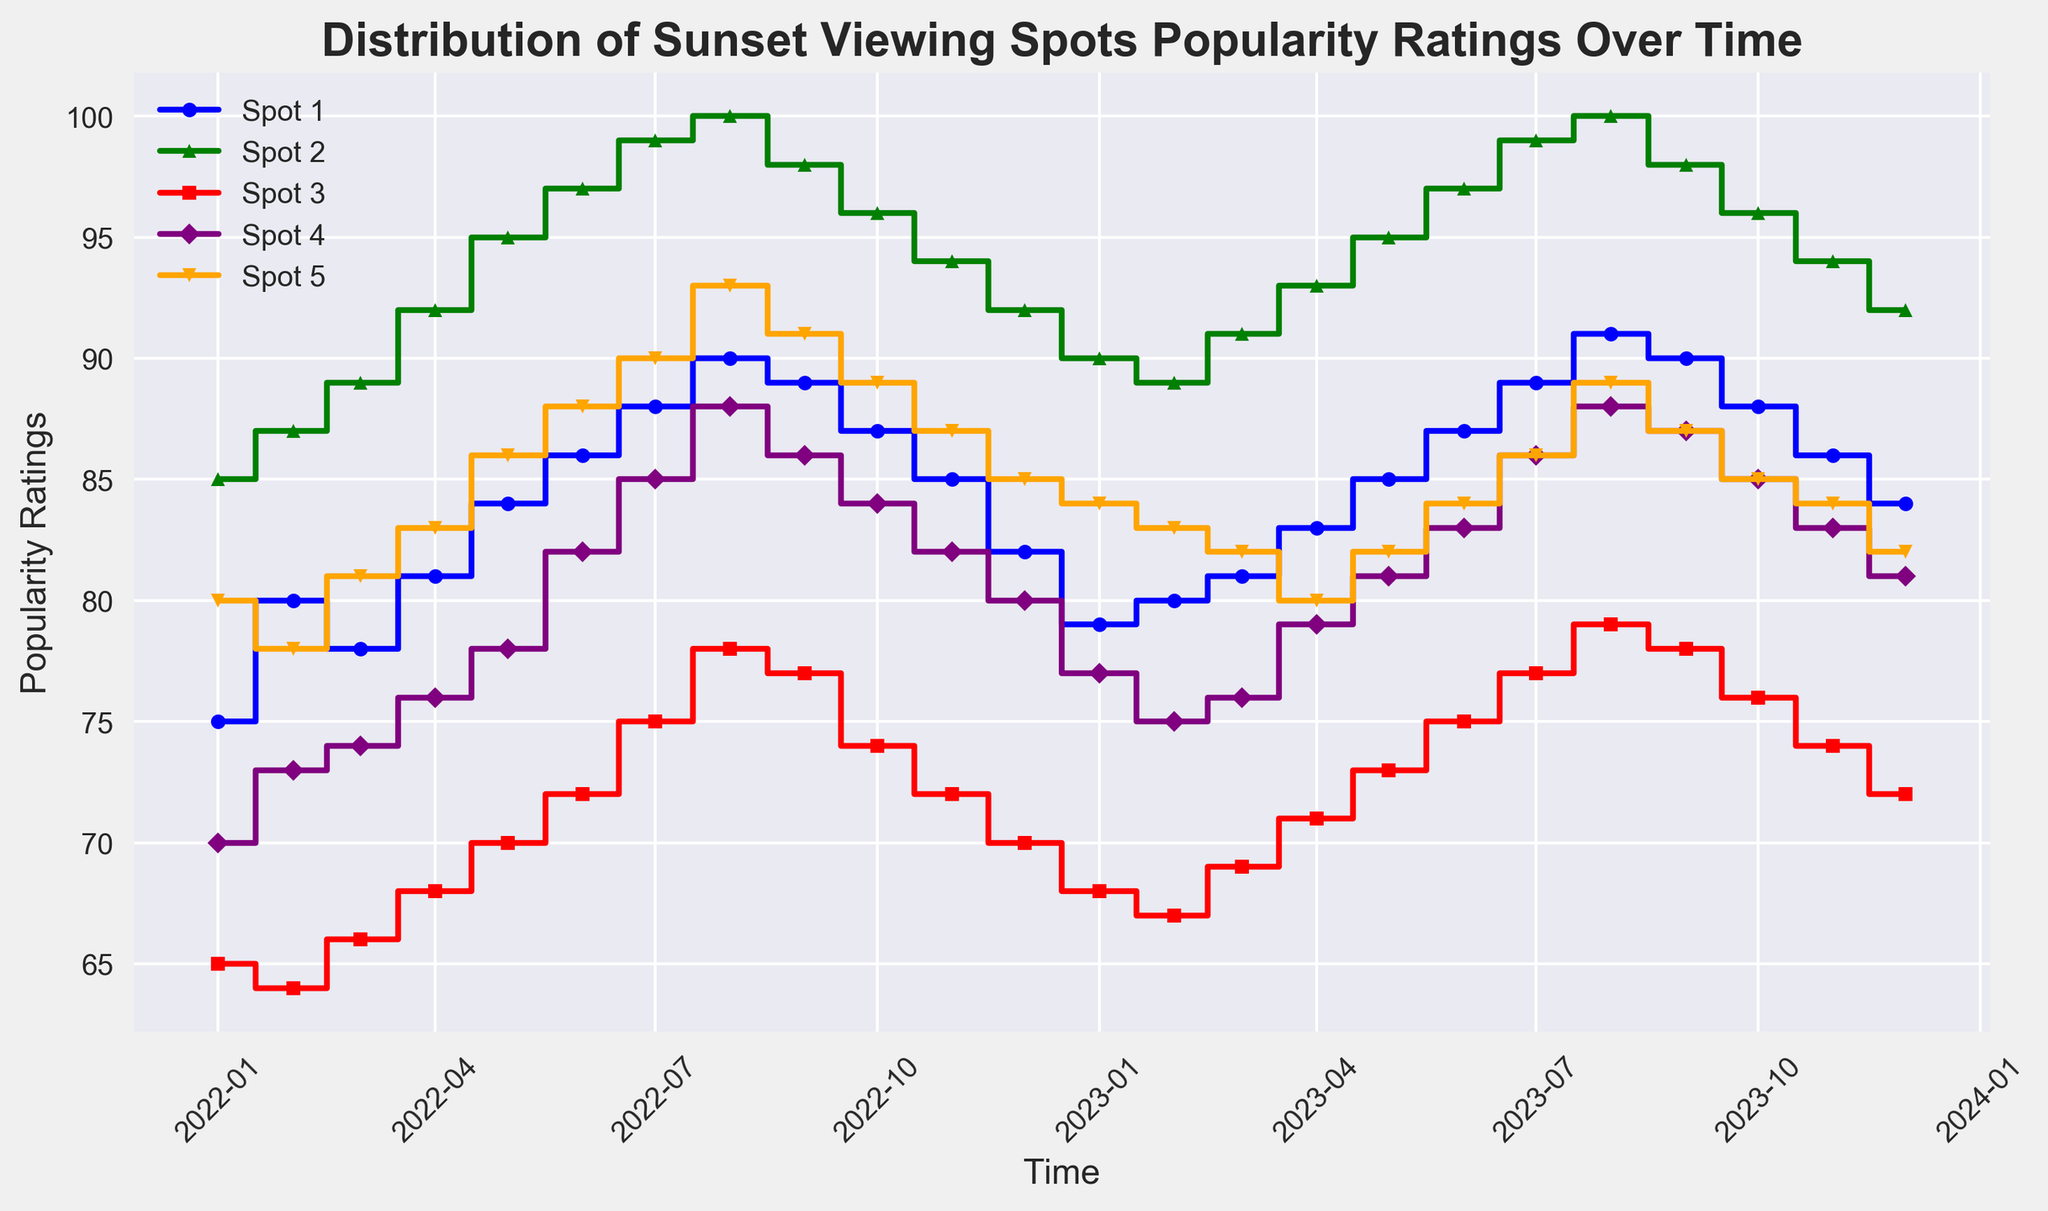**Question 1**  
What is the highest popularity rating for Spot 2 over the given time period? To find this, look at the data series for Spot 2 and identify the maximum value. The highest rating for Spot 2 is 100, which occurs in August 2022 and August 2023.
Answer: 100 **Question 2**  
Which month in 2023 has the lowest popularity rating for Spot 5? Examine the data series for Spot 5 for the year 2023 and note the lowest value. In April 2023, Spot 5 has its lowest rating, which is 80.
Answer: April 2023 **Question 3**  
How does the popularity rating trend for Spot 1 from July 2023 to October 2023? Look at how the values for Spot 1 change from July 2023 to October 2023. Spot 1 shows an increasing trend from July (89) to August (91), then decreases to September (90) and continues to fall in October (88).
Answer: Increasing then decreasing **Question 4**  
Which sunset viewing spot shows the most significant increase in popularity rating from January 2022 to December 2022? Compare the ratings for January 2022 and December 2022 for all spots. Spot 2 shows the largest increase, from 85 to 92, which is a 7-point increase.
Answer: Spot 2 **Question 5**  
What is the average popularity rating of Spot 3 in 2022? To find the average, sum the ratings of Spot 3 from January 2022 to December 2022 and divide by 12. The sum is 65 + 64 + 66 + 68 + 70 + 72 + 75 + 78 + 77 + 74 + 72 + 70 = 851. Thus, the average is 851 / 12 ≈ 70.92.
Answer: 70.92 **Question 6**  
Compare the popularity rating trends of Spot 4 and Spot 5 from June 2022 to June 2023. Who has a steadier trend over this period? Examine the ratings of Spot 4 and Spot 5 from June 2022 to June 2023. Spot 4 varies between 82 and 88, while Spot 5 varies between 85 and 84. Spot 5 shows a more consistent trend with lesser fluctuations.
Answer: Spot 5 **Question 7**  
Which sunset viewing spot has the highest fluctuation in popularity ratings from January 2023 to December 2023? To determine this, find the range (difference between the highest and lowest values) for each spot in 2023 and compare. Spot 5 ranges from 89 to 82 (variance 7), Spot 4 from 88 to 76 (variance 12), Spot 3 from 79 to 67 (variance 12), Spot 2 from 100 to 89 (variance 11), and Spot 1 from 91 to 79 (variance 12). Spot 3, 4, and 1 all show similar high fluctuations.
Answer: Spot 3, Spot 4, Spot 1 **Question 8**  
By how many points does the popularity rating for Spot 5 change from December 2022 to January 2023? Look at the ratings for Spot 5 in December 2022 (85) and January 2023 (84) and calculate the difference. 85 - 84 = 1.
Answer: 1 point **Question 9**  
Is there any month when Spot 1 has a higher rating than Spot 2? If yes, when? Compare the monthly ratings of Spot 1 and Spot 2. Spot 2 consistently has higher ratings than Spot 1 in all the given months.
Answer: No **Question 10**  
During which period does Spot 3 show the highest average popularity rating, and what is this average? Calculate the average ratings for Spot 3 in different periods and compare. For example, in the first half of 2022, sum (65+64+66+68+70+72)/6 = 67.5. During the second half, sum (75+78+77+74+72+70)/6 = 74.33. Spot 3 peaks in the second half of 2022 with an average of approximately 74.33.
Answer: Second half of 2022, 74.33 